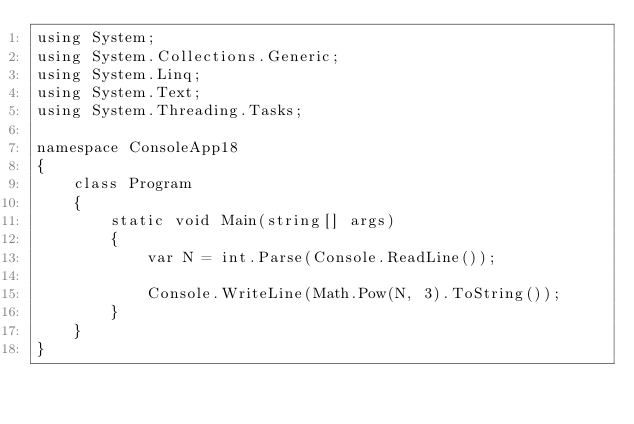Convert code to text. <code><loc_0><loc_0><loc_500><loc_500><_C#_>using System;
using System.Collections.Generic;
using System.Linq;
using System.Text;
using System.Threading.Tasks;

namespace ConsoleApp18
{
    class Program
    {
        static void Main(string[] args)
        {
            var N = int.Parse(Console.ReadLine());

            Console.WriteLine(Math.Pow(N, 3).ToString());
        }
    }
}
</code> 